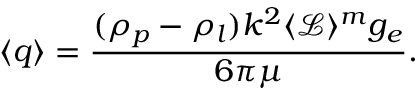Convert formula to latex. <formula><loc_0><loc_0><loc_500><loc_500>\langle q \rangle = \frac { ( \rho _ { p } - \rho _ { l } ) k ^ { 2 } \langle \mathcal { L } \rangle ^ { m } g _ { e } } { 6 \pi \mu } .</formula> 